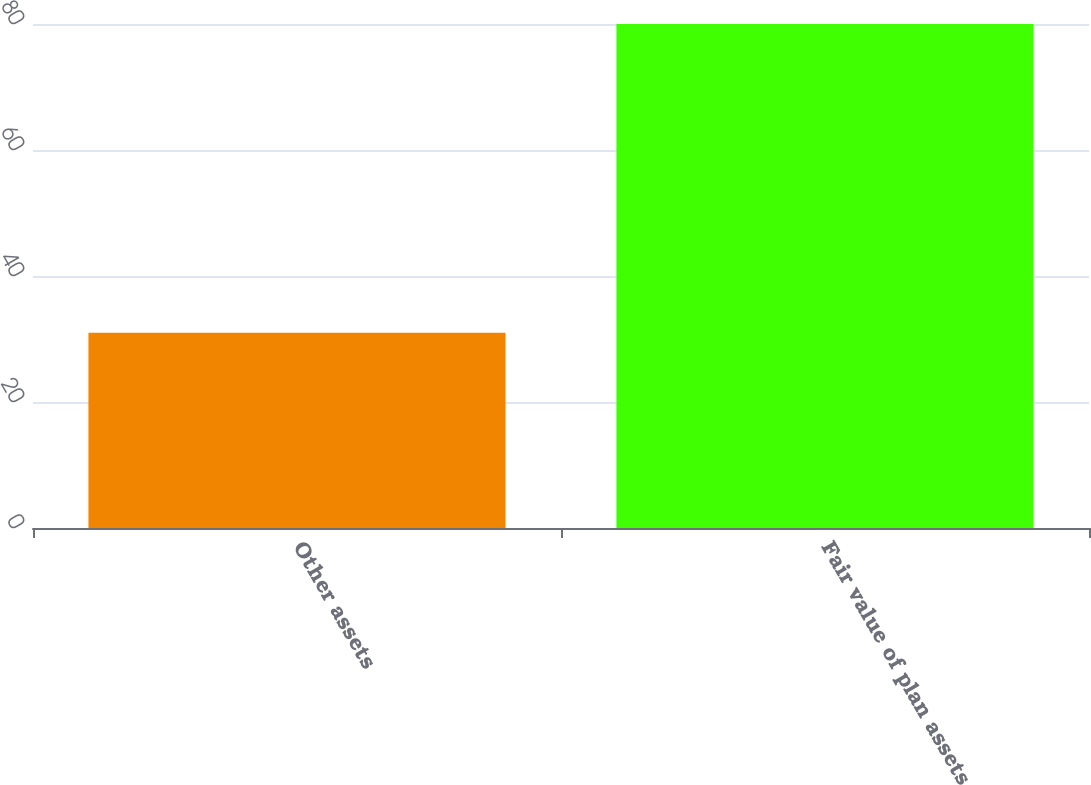Convert chart to OTSL. <chart><loc_0><loc_0><loc_500><loc_500><bar_chart><fcel>Other assets<fcel>Fair value of plan assets<nl><fcel>31<fcel>80<nl></chart> 